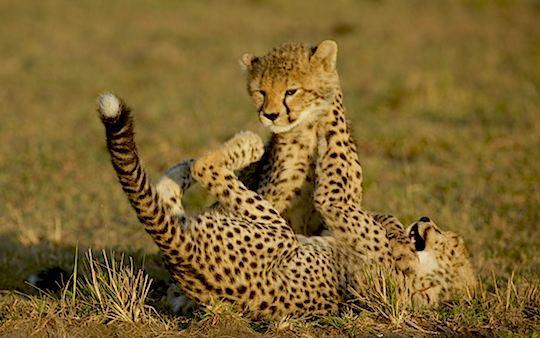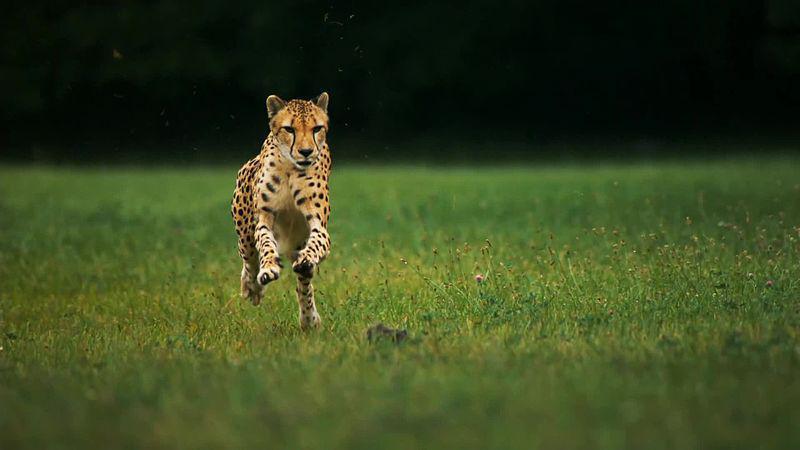The first image is the image on the left, the second image is the image on the right. Assess this claim about the two images: "There is a single cheetah in the left image and two cheetahs in the right image.". Correct or not? Answer yes or no. No. The first image is the image on the left, the second image is the image on the right. Analyze the images presented: Is the assertion "There are two cheetahs fighting with one of the cheetahs on its backside." valid? Answer yes or no. Yes. 